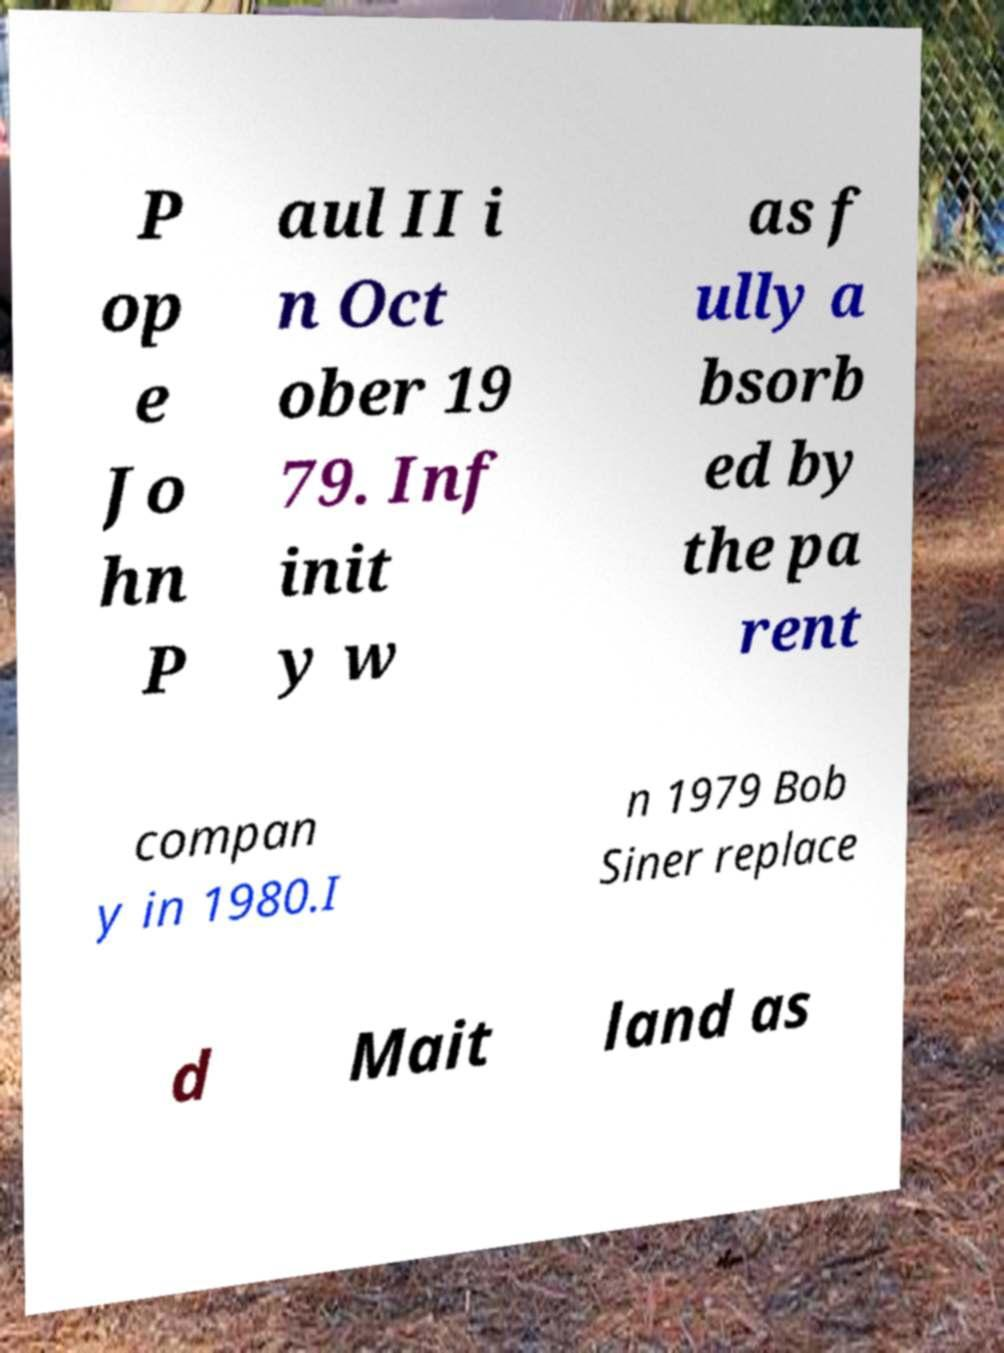Please read and relay the text visible in this image. What does it say? P op e Jo hn P aul II i n Oct ober 19 79. Inf init y w as f ully a bsorb ed by the pa rent compan y in 1980.I n 1979 Bob Siner replace d Mait land as 